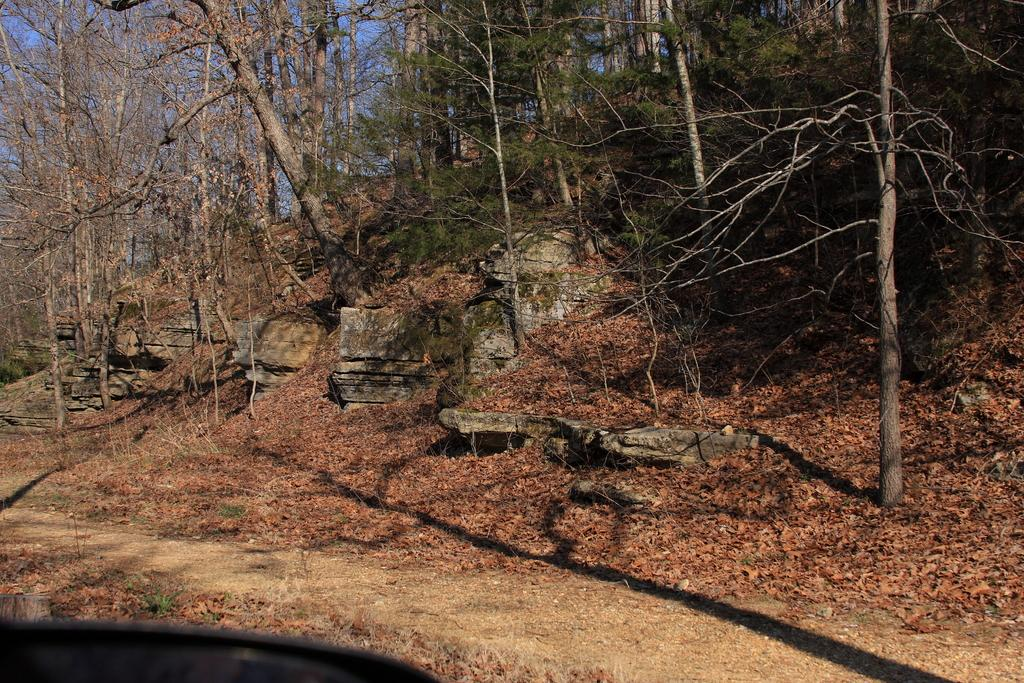What type of natural elements can be seen in the image? There are trees and rocks in the image. What might be covering the ground in the image? Shredded leaves are present at the bottom of the image. What is visible in the background of the image? The sky is visible in the background of the image. What type of planes can be seen flying over the seashore in the image? There is no seashore, or planes present in the image. 